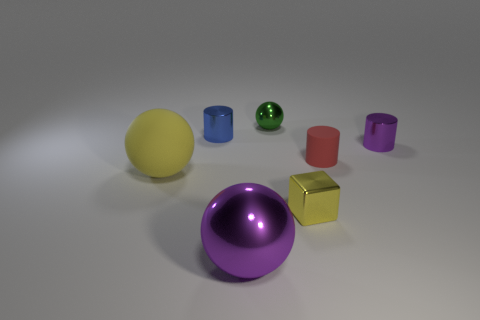There is a sphere that is the same color as the tiny metal block; what is its size?
Make the answer very short. Large. Does the big thing in front of the yellow matte sphere have the same shape as the green thing?
Ensure brevity in your answer.  Yes. Do the yellow metallic cube and the purple metal thing that is on the right side of the big purple sphere have the same size?
Keep it short and to the point. Yes. How many other objects are the same color as the large matte ball?
Keep it short and to the point. 1. There is a large yellow matte sphere; are there any shiny balls in front of it?
Keep it short and to the point. Yes. How many objects are either brown matte cylinders or metal spheres that are behind the small purple metallic cylinder?
Ensure brevity in your answer.  1. Are there any tiny shiny things on the left side of the purple metallic thing that is behind the block?
Give a very brief answer. Yes. There is a rubber thing that is to the right of the small shiny object in front of the matte thing that is behind the yellow matte sphere; what is its shape?
Make the answer very short. Cylinder. What color is the sphere that is both in front of the purple metal cylinder and right of the big matte thing?
Offer a very short reply. Purple. What shape is the green object that is to the left of the small purple metal cylinder?
Provide a short and direct response. Sphere. 